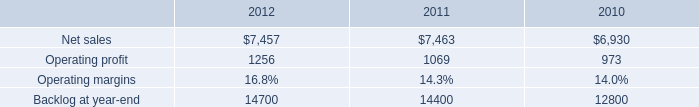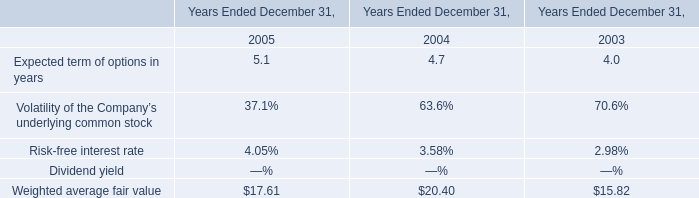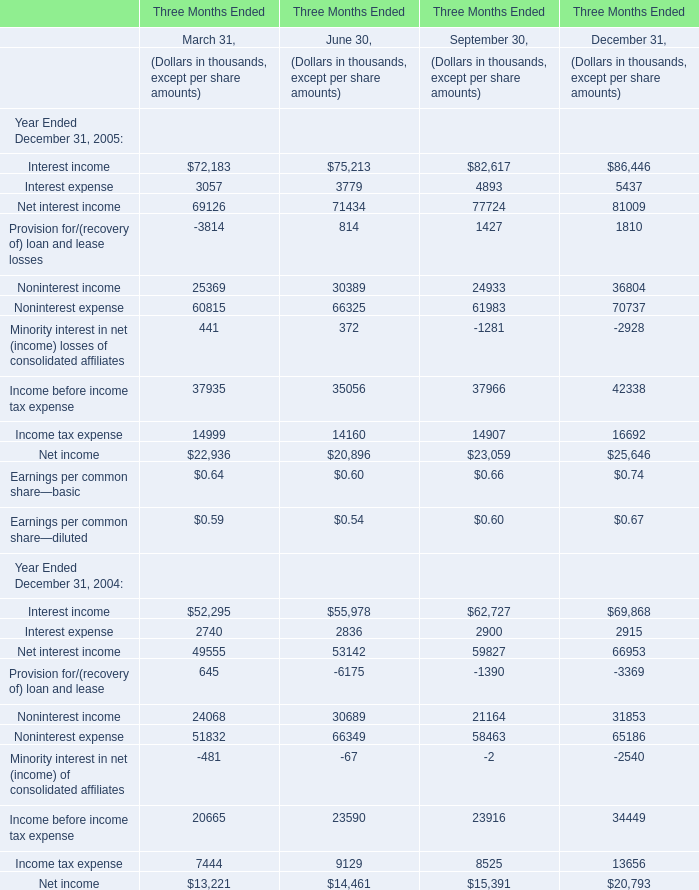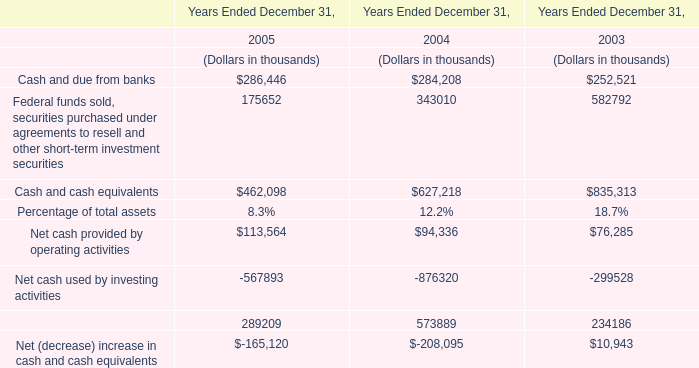What's the total amount of the Weighted average fair value in the years where Interest income for March 31, is greater than 0? 
Computations: (17.61 + 20.40)
Answer: 38.01. 